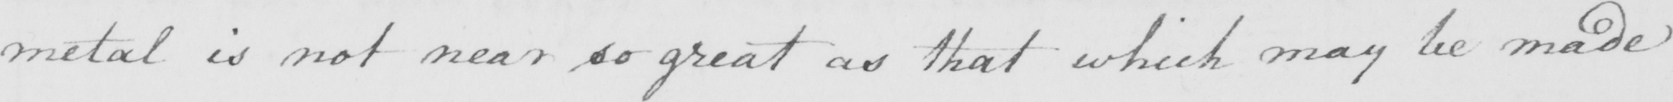What text is written in this handwritten line? metal is not near so great as that which may be made 